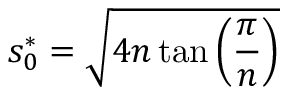Convert formula to latex. <formula><loc_0><loc_0><loc_500><loc_500>s _ { 0 } ^ { * } = \sqrt { 4 n \tan \left ( \frac { \pi } { n } \right ) }</formula> 